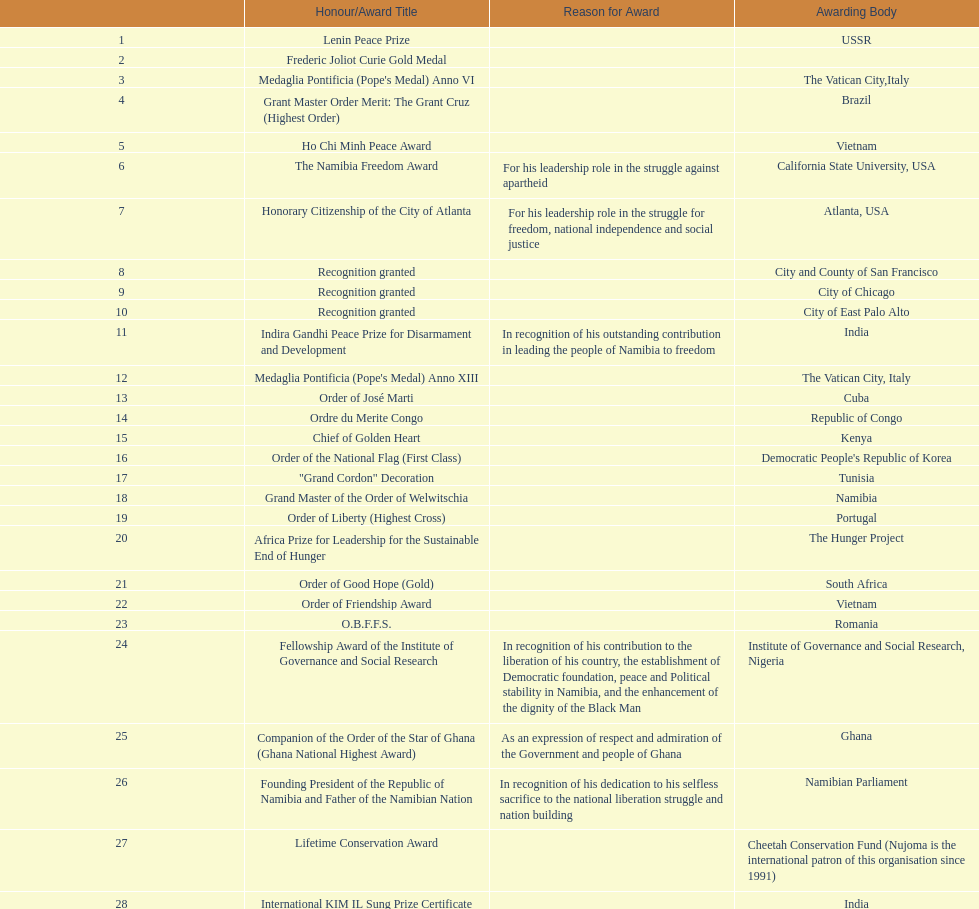On this chart, which title represents the most recent honors/award? Sir Seretse Khama SADC Meda. Could you parse the entire table? {'header': ['', 'Honour/Award Title', 'Reason for Award', 'Awarding Body'], 'rows': [['1', 'Lenin Peace Prize', '', 'USSR'], ['2', 'Frederic Joliot Curie Gold Medal', '', ''], ['3', "Medaglia Pontificia (Pope's Medal) Anno VI", '', 'The Vatican City,Italy'], ['4', 'Grant Master Order Merit: The Grant Cruz (Highest Order)', '', 'Brazil'], ['5', 'Ho Chi Minh Peace Award', '', 'Vietnam'], ['6', 'The Namibia Freedom Award', 'For his leadership role in the struggle against apartheid', 'California State University, USA'], ['7', 'Honorary Citizenship of the City of Atlanta', 'For his leadership role in the struggle for freedom, national independence and social justice', 'Atlanta, USA'], ['8', 'Recognition granted', '', 'City and County of San Francisco'], ['9', 'Recognition granted', '', 'City of Chicago'], ['10', 'Recognition granted', '', 'City of East Palo Alto'], ['11', 'Indira Gandhi Peace Prize for Disarmament and Development', 'In recognition of his outstanding contribution in leading the people of Namibia to freedom', 'India'], ['12', "Medaglia Pontificia (Pope's Medal) Anno XIII", '', 'The Vatican City, Italy'], ['13', 'Order of José Marti', '', 'Cuba'], ['14', 'Ordre du Merite Congo', '', 'Republic of Congo'], ['15', 'Chief of Golden Heart', '', 'Kenya'], ['16', 'Order of the National Flag (First Class)', '', "Democratic People's Republic of Korea"], ['17', '"Grand Cordon" Decoration', '', 'Tunisia'], ['18', 'Grand Master of the Order of Welwitschia', '', 'Namibia'], ['19', 'Order of Liberty (Highest Cross)', '', 'Portugal'], ['20', 'Africa Prize for Leadership for the Sustainable End of Hunger', '', 'The Hunger Project'], ['21', 'Order of Good Hope (Gold)', '', 'South Africa'], ['22', 'Order of Friendship Award', '', 'Vietnam'], ['23', 'O.B.F.F.S.', '', 'Romania'], ['24', 'Fellowship Award of the Institute of Governance and Social Research', 'In recognition of his contribution to the liberation of his country, the establishment of Democratic foundation, peace and Political stability in Namibia, and the enhancement of the dignity of the Black Man', 'Institute of Governance and Social Research, Nigeria'], ['25', 'Companion of the Order of the Star of Ghana (Ghana National Highest Award)', 'As an expression of respect and admiration of the Government and people of Ghana', 'Ghana'], ['26', 'Founding President of the Republic of Namibia and Father of the Namibian Nation', 'In recognition of his dedication to his selfless sacrifice to the national liberation struggle and nation building', 'Namibian Parliament'], ['27', 'Lifetime Conservation Award', '', 'Cheetah Conservation Fund (Nujoma is the international patron of this organisation since 1991)'], ['28', 'International KIM IL Sung Prize Certificate', '', 'India'], ['29', 'Sir Seretse Khama SADC Meda', '', 'SADC']]} 